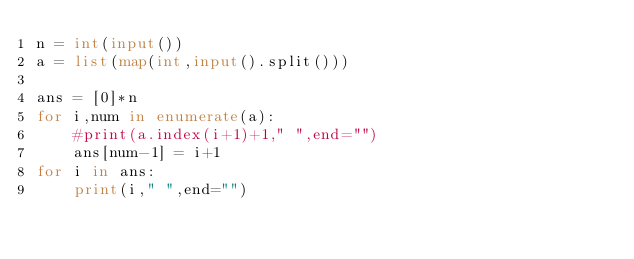<code> <loc_0><loc_0><loc_500><loc_500><_Python_>n = int(input())
a = list(map(int,input().split()))

ans = [0]*n
for i,num in enumerate(a):
    #print(a.index(i+1)+1," ",end="")
    ans[num-1] = i+1
for i in ans:
    print(i," ",end="")
</code> 